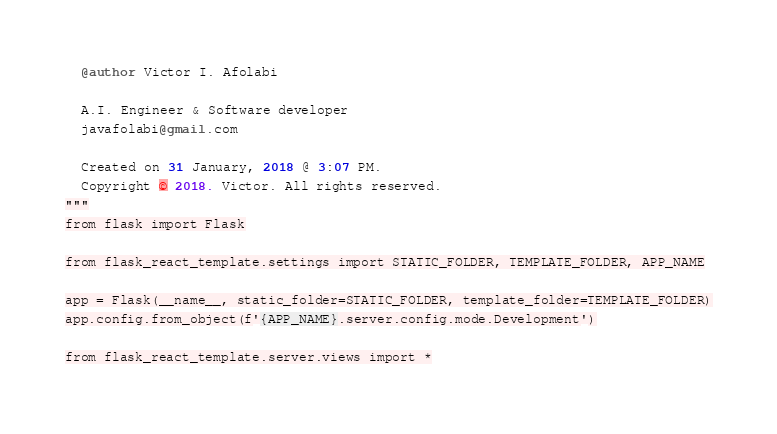Convert code to text. <code><loc_0><loc_0><loc_500><loc_500><_Python_>  @author Victor I. Afolabi
  
  A.I. Engineer & Software developer
  javafolabi@gmail.com
  
  Created on 31 January, 2018 @ 3:07 PM.
  Copyright © 2018. Victor. All rights reserved.
"""
from flask import Flask

from flask_react_template.settings import STATIC_FOLDER, TEMPLATE_FOLDER, APP_NAME

app = Flask(__name__, static_folder=STATIC_FOLDER, template_folder=TEMPLATE_FOLDER)
app.config.from_object(f'{APP_NAME}.server.config.mode.Development')

from flask_react_template.server.views import *
</code> 